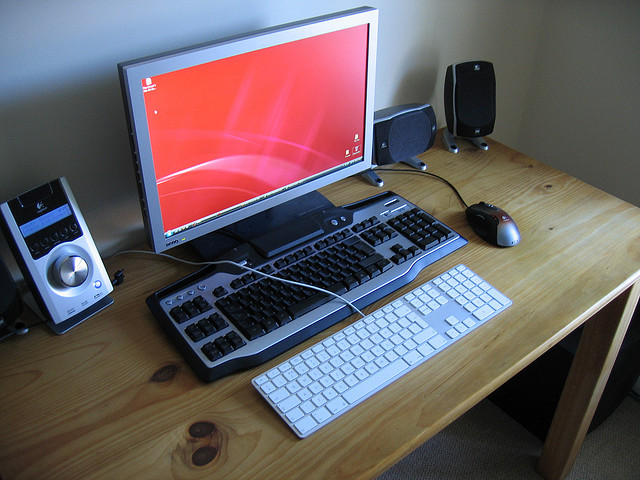<image>What material is this table made of? I am not sure about the material of the table. But it can be made of wood. What material is this table made of? The table is made of wood. 